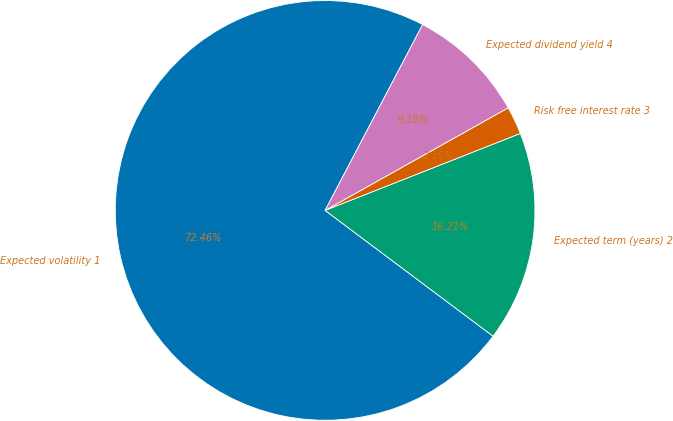Convert chart to OTSL. <chart><loc_0><loc_0><loc_500><loc_500><pie_chart><fcel>Expected volatility 1<fcel>Expected term (years) 2<fcel>Risk free interest rate 3<fcel>Expected dividend yield 4<nl><fcel>72.46%<fcel>16.21%<fcel>2.15%<fcel>9.18%<nl></chart> 